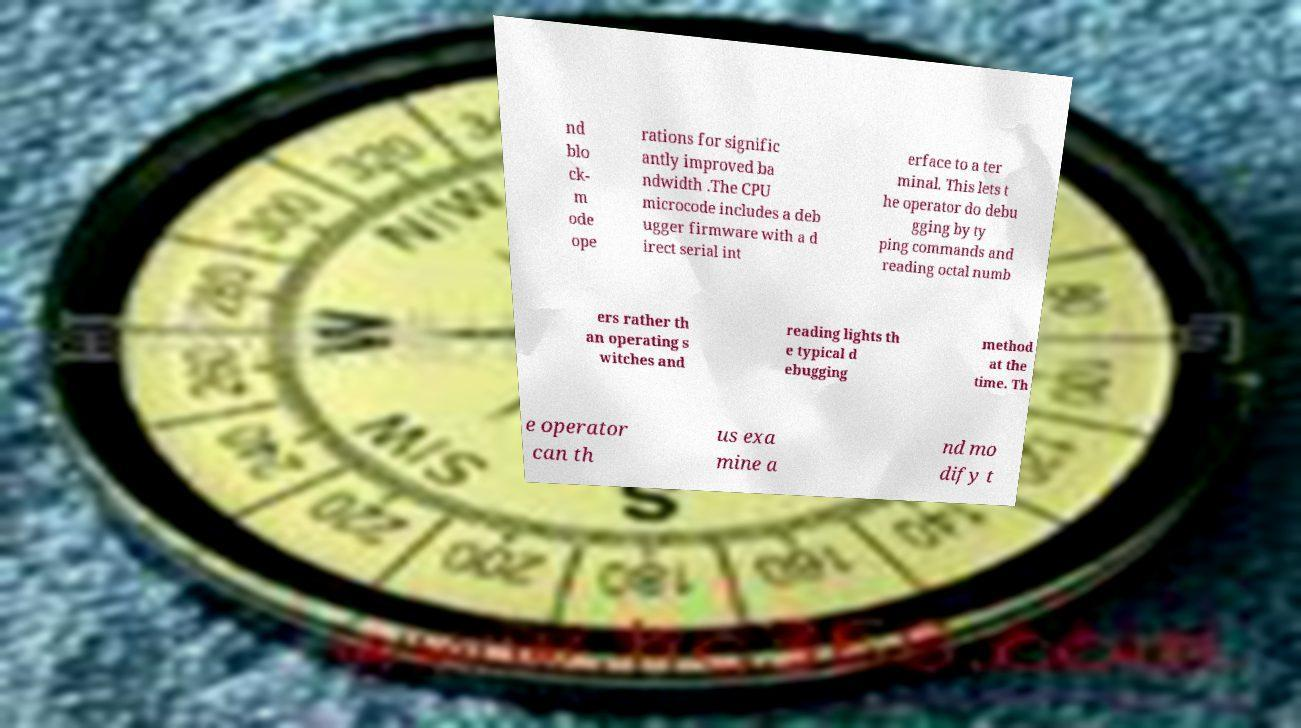For documentation purposes, I need the text within this image transcribed. Could you provide that? nd blo ck- m ode ope rations for signific antly improved ba ndwidth .The CPU microcode includes a deb ugger firmware with a d irect serial int erface to a ter minal. This lets t he operator do debu gging by ty ping commands and reading octal numb ers rather th an operating s witches and reading lights th e typical d ebugging method at the time. Th e operator can th us exa mine a nd mo dify t 